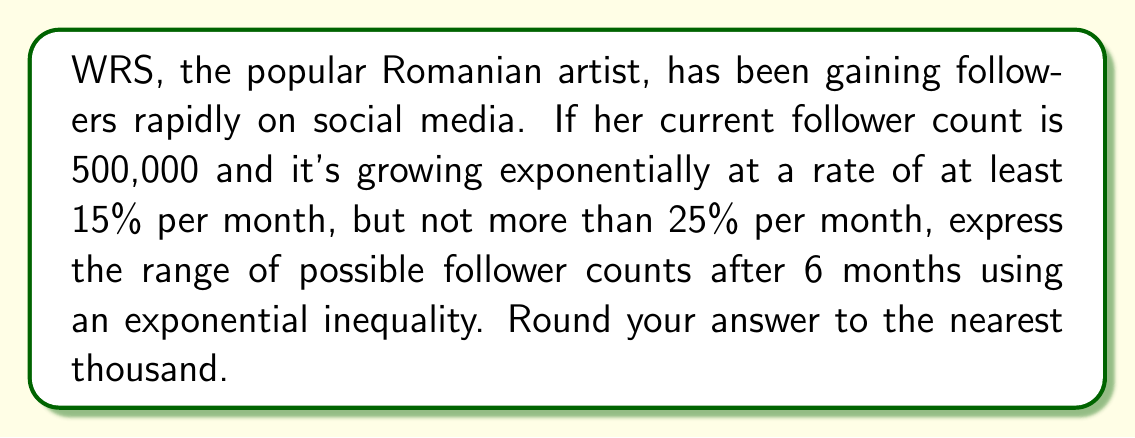Show me your answer to this math problem. Let's approach this step-by-step:

1) The general formula for exponential growth is $A = P(1+r)^t$, where:
   $A$ is the final amount
   $P$ is the initial amount (500,000)
   $r$ is the growth rate (between 0.15 and 0.25)
   $t$ is the time period (6 months)

2) We need to set up two inequalities, one for the lower bound and one for the upper bound:

   Lower bound: $500,000(1+0.15)^6 \leq A$
   Upper bound: $A \leq 500,000(1+0.25)^6$

3) Let's calculate the lower bound:
   $500,000(1+0.15)^6 = 500,000(1.15)^6 \approx 1,153,735$

4) Now the upper bound:
   $500,000(1+0.25)^6 = 500,000(1.25)^6 \approx 1,907,349$

5) Rounding to the nearest thousand:
   $1,154,000 \leq A \leq 1,907,000$

Therefore, the range of possible follower counts after 6 months can be expressed as:

$$1,154,000 \leq A \leq 1,907,000$$

Where $A$ represents WRS's follower count after 6 months.
Answer: $1,154,000 \leq A \leq 1,907,000$ 